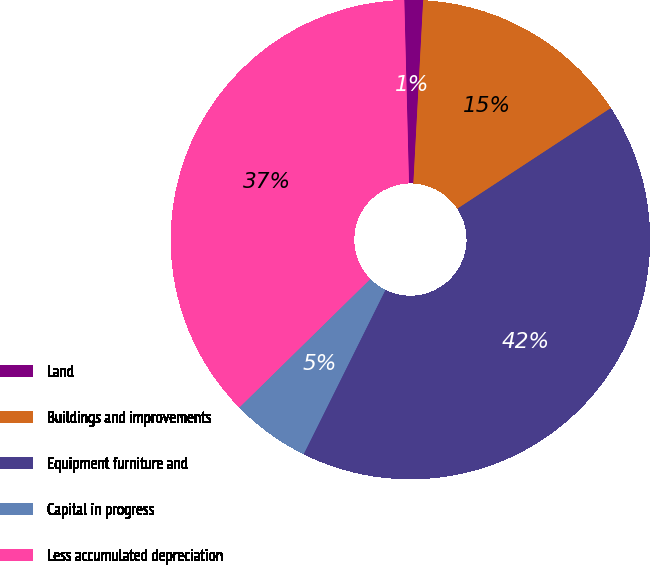Convert chart to OTSL. <chart><loc_0><loc_0><loc_500><loc_500><pie_chart><fcel>Land<fcel>Buildings and improvements<fcel>Equipment furniture and<fcel>Capital in progress<fcel>Less accumulated depreciation<nl><fcel>1.26%<fcel>14.91%<fcel>41.59%<fcel>5.3%<fcel>36.94%<nl></chart> 